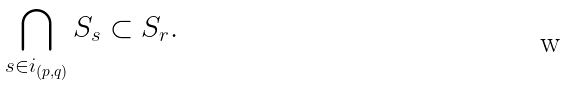<formula> <loc_0><loc_0><loc_500><loc_500>\bigcap _ { s \in i _ { \left ( p , q \right ) } } S _ { s } \subset S _ { r } .</formula> 